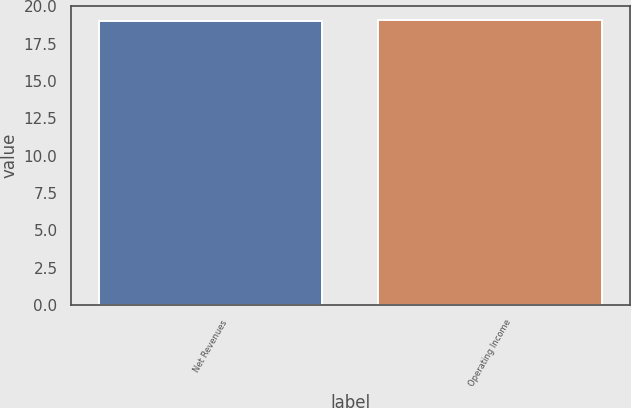Convert chart. <chart><loc_0><loc_0><loc_500><loc_500><bar_chart><fcel>Net Revenues<fcel>Operating Income<nl><fcel>19<fcel>19.1<nl></chart> 